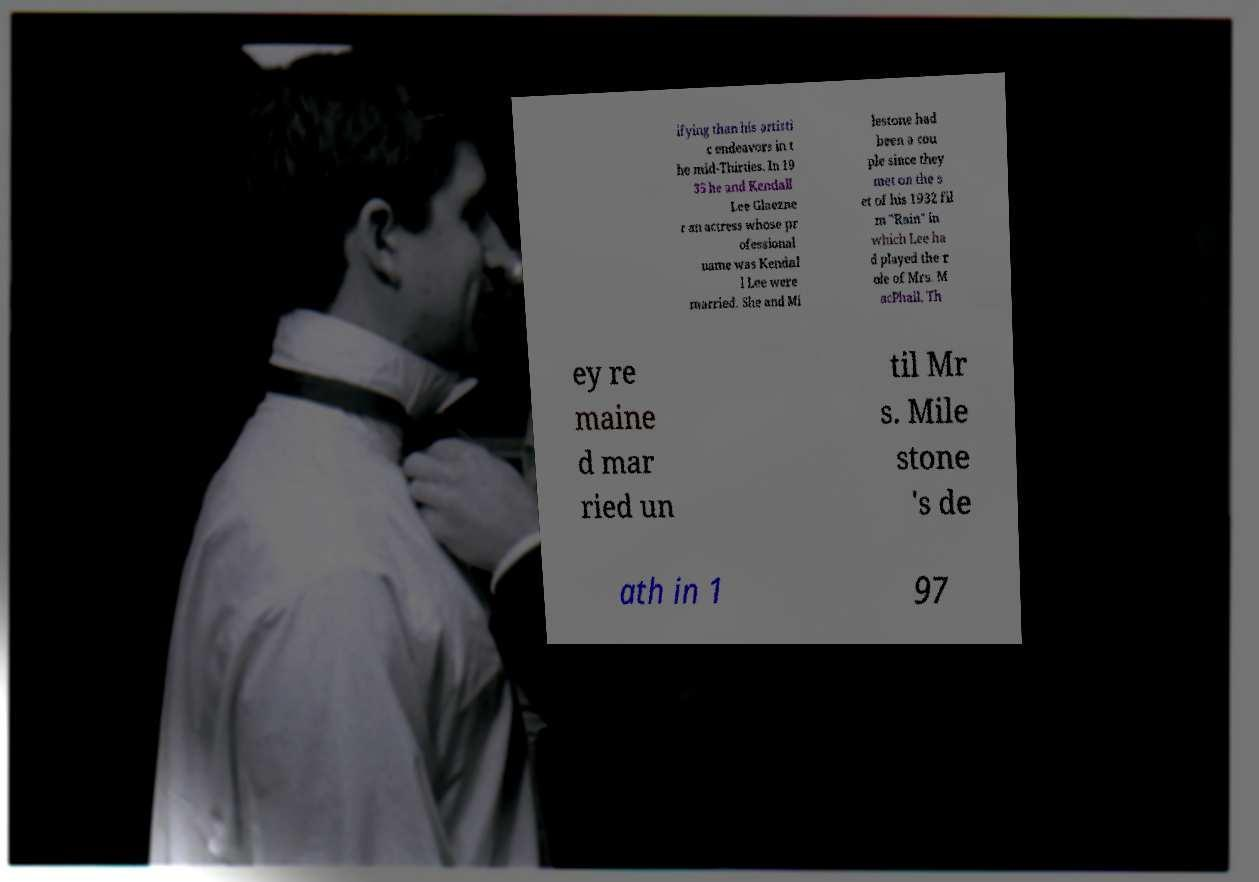Could you assist in decoding the text presented in this image and type it out clearly? ifying than his artisti c endeavors in t he mid-Thirties. In 19 35 he and Kendall Lee Glaezne r an actress whose pr ofessional name was Kendal l Lee were married. She and Mi lestone had been a cou ple since they met on the s et of his 1932 fil m "Rain" in which Lee ha d played the r ole of Mrs. M acPhail. Th ey re maine d mar ried un til Mr s. Mile stone 's de ath in 1 97 